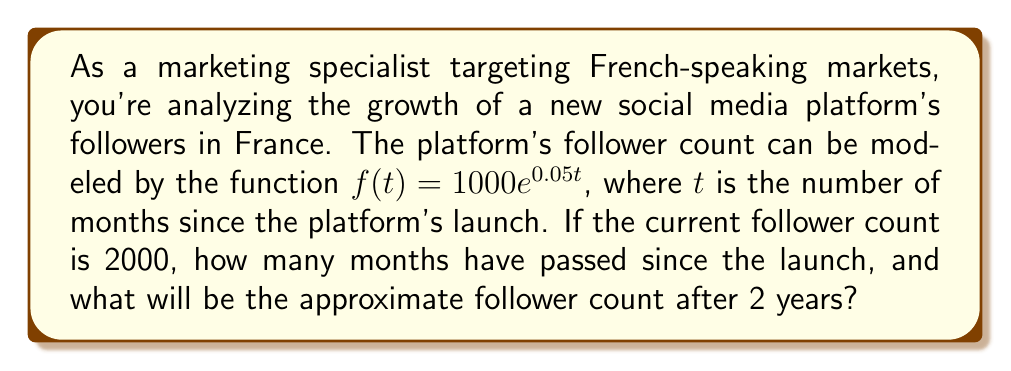Show me your answer to this math problem. 1. To find the number of months since launch:
   We know that $f(t) = 2000$ (current follower count)
   $$1000e^{0.05t} = 2000$$

2. Divide both sides by 1000:
   $$e^{0.05t} = 2$$

3. Take the natural logarithm of both sides:
   $$\ln(e^{0.05t}) = \ln(2)$$
   $$0.05t = \ln(2)$$

4. Solve for $t$:
   $$t = \frac{\ln(2)}{0.05} \approx 13.86$$

5. To find the follower count after 2 years (24 months):
   $$f(24) = 1000e^{0.05(24)}$$
   $$f(24) = 1000e^{1.2}$$
   $$f(24) = 1000 * 3.32$$
   $$f(24) \approx 3320$$
Answer: 13.86 months; 3320 followers 